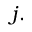Convert formula to latex. <formula><loc_0><loc_0><loc_500><loc_500>j .</formula> 